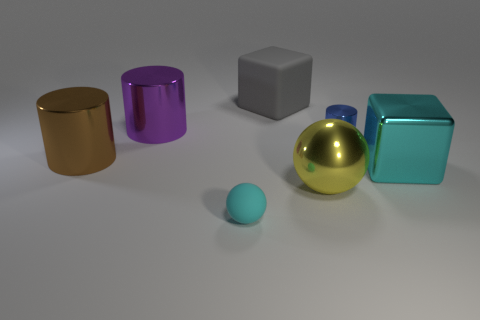Subtract all large cylinders. How many cylinders are left? 1 Subtract all brown cubes. How many green spheres are left? 0 Subtract all large blue spheres. Subtract all tiny balls. How many objects are left? 6 Add 1 cylinders. How many cylinders are left? 4 Add 4 brown objects. How many brown objects exist? 5 Add 1 cyan blocks. How many objects exist? 8 Subtract all cyan spheres. How many spheres are left? 1 Subtract 1 cyan spheres. How many objects are left? 6 Subtract all balls. How many objects are left? 5 Subtract 1 cylinders. How many cylinders are left? 2 